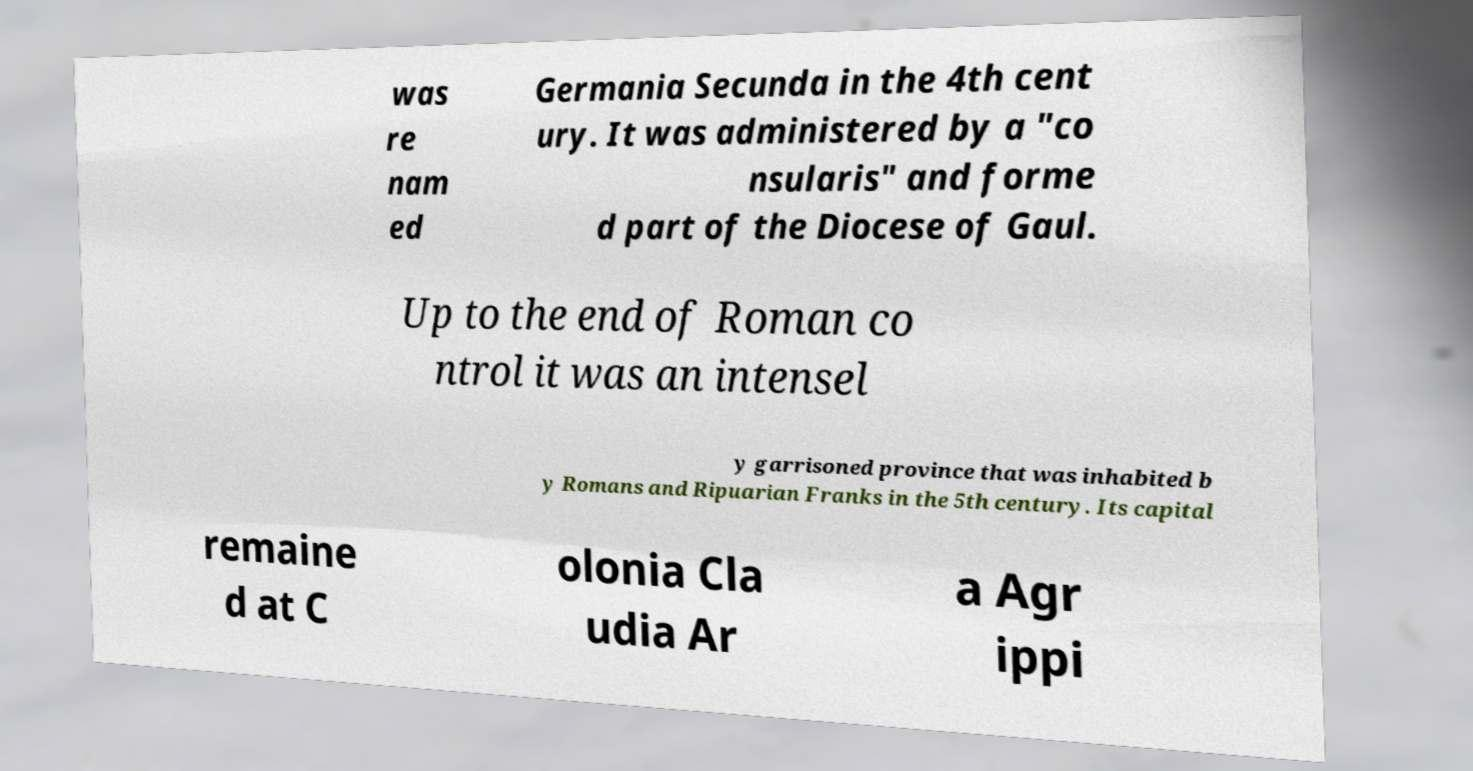Please read and relay the text visible in this image. What does it say? was re nam ed Germania Secunda in the 4th cent ury. It was administered by a "co nsularis" and forme d part of the Diocese of Gaul. Up to the end of Roman co ntrol it was an intensel y garrisoned province that was inhabited b y Romans and Ripuarian Franks in the 5th century. Its capital remaine d at C olonia Cla udia Ar a Agr ippi 